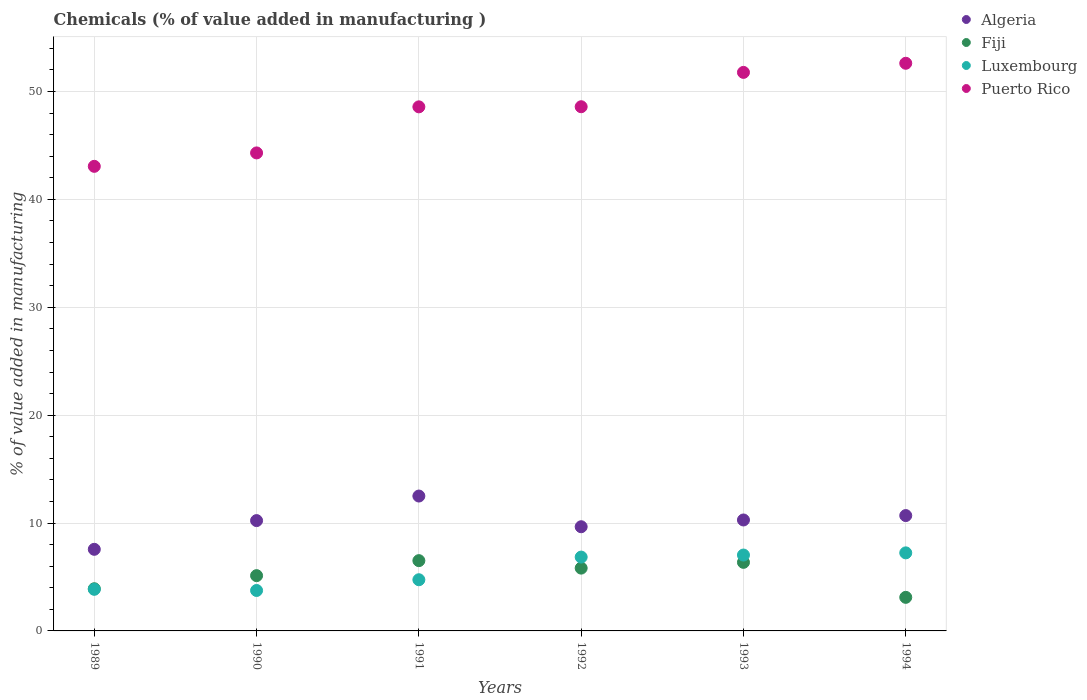How many different coloured dotlines are there?
Provide a short and direct response. 4. Is the number of dotlines equal to the number of legend labels?
Offer a terse response. Yes. What is the value added in manufacturing chemicals in Puerto Rico in 1992?
Provide a short and direct response. 48.59. Across all years, what is the maximum value added in manufacturing chemicals in Puerto Rico?
Give a very brief answer. 52.62. Across all years, what is the minimum value added in manufacturing chemicals in Luxembourg?
Offer a terse response. 3.75. In which year was the value added in manufacturing chemicals in Luxembourg maximum?
Provide a short and direct response. 1994. What is the total value added in manufacturing chemicals in Puerto Rico in the graph?
Provide a short and direct response. 288.94. What is the difference between the value added in manufacturing chemicals in Algeria in 1992 and that in 1994?
Offer a terse response. -1.03. What is the difference between the value added in manufacturing chemicals in Luxembourg in 1991 and the value added in manufacturing chemicals in Puerto Rico in 1990?
Ensure brevity in your answer.  -39.56. What is the average value added in manufacturing chemicals in Puerto Rico per year?
Provide a short and direct response. 48.16. In the year 1989, what is the difference between the value added in manufacturing chemicals in Puerto Rico and value added in manufacturing chemicals in Fiji?
Make the answer very short. 39.15. What is the ratio of the value added in manufacturing chemicals in Luxembourg in 1990 to that in 1993?
Keep it short and to the point. 0.53. Is the difference between the value added in manufacturing chemicals in Puerto Rico in 1992 and 1993 greater than the difference between the value added in manufacturing chemicals in Fiji in 1992 and 1993?
Give a very brief answer. No. What is the difference between the highest and the second highest value added in manufacturing chemicals in Puerto Rico?
Keep it short and to the point. 0.84. What is the difference between the highest and the lowest value added in manufacturing chemicals in Algeria?
Provide a short and direct response. 4.94. Is it the case that in every year, the sum of the value added in manufacturing chemicals in Puerto Rico and value added in manufacturing chemicals in Luxembourg  is greater than the sum of value added in manufacturing chemicals in Fiji and value added in manufacturing chemicals in Algeria?
Your answer should be very brief. Yes. Does the value added in manufacturing chemicals in Luxembourg monotonically increase over the years?
Provide a short and direct response. No. What is the difference between two consecutive major ticks on the Y-axis?
Provide a short and direct response. 10. Does the graph contain any zero values?
Offer a terse response. No. Where does the legend appear in the graph?
Your response must be concise. Top right. How many legend labels are there?
Provide a succinct answer. 4. What is the title of the graph?
Provide a short and direct response. Chemicals (% of value added in manufacturing ). Does "Sierra Leone" appear as one of the legend labels in the graph?
Your answer should be compact. No. What is the label or title of the Y-axis?
Your answer should be compact. % of value added in manufacturing. What is the % of value added in manufacturing of Algeria in 1989?
Your response must be concise. 7.56. What is the % of value added in manufacturing of Fiji in 1989?
Provide a short and direct response. 3.91. What is the % of value added in manufacturing of Luxembourg in 1989?
Make the answer very short. 3.86. What is the % of value added in manufacturing of Puerto Rico in 1989?
Ensure brevity in your answer.  43.07. What is the % of value added in manufacturing of Algeria in 1990?
Offer a very short reply. 10.23. What is the % of value added in manufacturing of Fiji in 1990?
Your answer should be compact. 5.12. What is the % of value added in manufacturing of Luxembourg in 1990?
Keep it short and to the point. 3.75. What is the % of value added in manufacturing in Puerto Rico in 1990?
Ensure brevity in your answer.  44.31. What is the % of value added in manufacturing of Algeria in 1991?
Provide a short and direct response. 12.5. What is the % of value added in manufacturing of Fiji in 1991?
Your answer should be compact. 6.51. What is the % of value added in manufacturing in Luxembourg in 1991?
Offer a terse response. 4.74. What is the % of value added in manufacturing of Puerto Rico in 1991?
Your answer should be compact. 48.58. What is the % of value added in manufacturing in Algeria in 1992?
Make the answer very short. 9.66. What is the % of value added in manufacturing of Fiji in 1992?
Your answer should be very brief. 5.82. What is the % of value added in manufacturing in Luxembourg in 1992?
Your answer should be compact. 6.84. What is the % of value added in manufacturing of Puerto Rico in 1992?
Give a very brief answer. 48.59. What is the % of value added in manufacturing in Algeria in 1993?
Your response must be concise. 10.28. What is the % of value added in manufacturing of Fiji in 1993?
Ensure brevity in your answer.  6.36. What is the % of value added in manufacturing in Luxembourg in 1993?
Your answer should be very brief. 7.03. What is the % of value added in manufacturing in Puerto Rico in 1993?
Keep it short and to the point. 51.77. What is the % of value added in manufacturing in Algeria in 1994?
Offer a terse response. 10.69. What is the % of value added in manufacturing of Fiji in 1994?
Offer a terse response. 3.11. What is the % of value added in manufacturing of Luxembourg in 1994?
Your response must be concise. 7.24. What is the % of value added in manufacturing of Puerto Rico in 1994?
Keep it short and to the point. 52.62. Across all years, what is the maximum % of value added in manufacturing in Algeria?
Ensure brevity in your answer.  12.5. Across all years, what is the maximum % of value added in manufacturing in Fiji?
Your response must be concise. 6.51. Across all years, what is the maximum % of value added in manufacturing of Luxembourg?
Ensure brevity in your answer.  7.24. Across all years, what is the maximum % of value added in manufacturing of Puerto Rico?
Provide a succinct answer. 52.62. Across all years, what is the minimum % of value added in manufacturing in Algeria?
Your response must be concise. 7.56. Across all years, what is the minimum % of value added in manufacturing in Fiji?
Your response must be concise. 3.11. Across all years, what is the minimum % of value added in manufacturing in Luxembourg?
Keep it short and to the point. 3.75. Across all years, what is the minimum % of value added in manufacturing in Puerto Rico?
Your answer should be compact. 43.07. What is the total % of value added in manufacturing in Algeria in the graph?
Make the answer very short. 60.93. What is the total % of value added in manufacturing of Fiji in the graph?
Provide a succinct answer. 30.84. What is the total % of value added in manufacturing of Luxembourg in the graph?
Your answer should be very brief. 33.46. What is the total % of value added in manufacturing in Puerto Rico in the graph?
Your answer should be compact. 288.94. What is the difference between the % of value added in manufacturing of Algeria in 1989 and that in 1990?
Provide a short and direct response. -2.66. What is the difference between the % of value added in manufacturing of Fiji in 1989 and that in 1990?
Keep it short and to the point. -1.21. What is the difference between the % of value added in manufacturing in Luxembourg in 1989 and that in 1990?
Your answer should be compact. 0.11. What is the difference between the % of value added in manufacturing of Puerto Rico in 1989 and that in 1990?
Offer a terse response. -1.24. What is the difference between the % of value added in manufacturing in Algeria in 1989 and that in 1991?
Give a very brief answer. -4.94. What is the difference between the % of value added in manufacturing of Fiji in 1989 and that in 1991?
Make the answer very short. -2.6. What is the difference between the % of value added in manufacturing in Luxembourg in 1989 and that in 1991?
Offer a very short reply. -0.89. What is the difference between the % of value added in manufacturing in Puerto Rico in 1989 and that in 1991?
Make the answer very short. -5.51. What is the difference between the % of value added in manufacturing in Algeria in 1989 and that in 1992?
Ensure brevity in your answer.  -2.09. What is the difference between the % of value added in manufacturing in Fiji in 1989 and that in 1992?
Your response must be concise. -1.91. What is the difference between the % of value added in manufacturing in Luxembourg in 1989 and that in 1992?
Provide a short and direct response. -2.99. What is the difference between the % of value added in manufacturing of Puerto Rico in 1989 and that in 1992?
Offer a terse response. -5.53. What is the difference between the % of value added in manufacturing of Algeria in 1989 and that in 1993?
Your response must be concise. -2.72. What is the difference between the % of value added in manufacturing in Fiji in 1989 and that in 1993?
Make the answer very short. -2.45. What is the difference between the % of value added in manufacturing of Luxembourg in 1989 and that in 1993?
Your answer should be compact. -3.18. What is the difference between the % of value added in manufacturing of Puerto Rico in 1989 and that in 1993?
Offer a terse response. -8.71. What is the difference between the % of value added in manufacturing of Algeria in 1989 and that in 1994?
Give a very brief answer. -3.13. What is the difference between the % of value added in manufacturing of Fiji in 1989 and that in 1994?
Give a very brief answer. 0.8. What is the difference between the % of value added in manufacturing in Luxembourg in 1989 and that in 1994?
Give a very brief answer. -3.38. What is the difference between the % of value added in manufacturing of Puerto Rico in 1989 and that in 1994?
Offer a very short reply. -9.55. What is the difference between the % of value added in manufacturing of Algeria in 1990 and that in 1991?
Provide a succinct answer. -2.28. What is the difference between the % of value added in manufacturing of Fiji in 1990 and that in 1991?
Offer a very short reply. -1.39. What is the difference between the % of value added in manufacturing of Luxembourg in 1990 and that in 1991?
Provide a short and direct response. -1. What is the difference between the % of value added in manufacturing in Puerto Rico in 1990 and that in 1991?
Your response must be concise. -4.27. What is the difference between the % of value added in manufacturing in Algeria in 1990 and that in 1992?
Keep it short and to the point. 0.57. What is the difference between the % of value added in manufacturing in Fiji in 1990 and that in 1992?
Your answer should be compact. -0.7. What is the difference between the % of value added in manufacturing in Luxembourg in 1990 and that in 1992?
Provide a succinct answer. -3.1. What is the difference between the % of value added in manufacturing of Puerto Rico in 1990 and that in 1992?
Offer a terse response. -4.28. What is the difference between the % of value added in manufacturing in Algeria in 1990 and that in 1993?
Provide a short and direct response. -0.06. What is the difference between the % of value added in manufacturing of Fiji in 1990 and that in 1993?
Your response must be concise. -1.23. What is the difference between the % of value added in manufacturing of Luxembourg in 1990 and that in 1993?
Keep it short and to the point. -3.29. What is the difference between the % of value added in manufacturing of Puerto Rico in 1990 and that in 1993?
Keep it short and to the point. -7.46. What is the difference between the % of value added in manufacturing in Algeria in 1990 and that in 1994?
Ensure brevity in your answer.  -0.47. What is the difference between the % of value added in manufacturing in Fiji in 1990 and that in 1994?
Your answer should be compact. 2.01. What is the difference between the % of value added in manufacturing of Luxembourg in 1990 and that in 1994?
Your response must be concise. -3.49. What is the difference between the % of value added in manufacturing in Puerto Rico in 1990 and that in 1994?
Your response must be concise. -8.31. What is the difference between the % of value added in manufacturing in Algeria in 1991 and that in 1992?
Your answer should be very brief. 2.85. What is the difference between the % of value added in manufacturing of Fiji in 1991 and that in 1992?
Provide a succinct answer. 0.69. What is the difference between the % of value added in manufacturing in Luxembourg in 1991 and that in 1992?
Your answer should be compact. -2.1. What is the difference between the % of value added in manufacturing in Puerto Rico in 1991 and that in 1992?
Keep it short and to the point. -0.01. What is the difference between the % of value added in manufacturing of Algeria in 1991 and that in 1993?
Keep it short and to the point. 2.22. What is the difference between the % of value added in manufacturing of Fiji in 1991 and that in 1993?
Offer a terse response. 0.16. What is the difference between the % of value added in manufacturing of Luxembourg in 1991 and that in 1993?
Ensure brevity in your answer.  -2.29. What is the difference between the % of value added in manufacturing in Puerto Rico in 1991 and that in 1993?
Your response must be concise. -3.19. What is the difference between the % of value added in manufacturing of Algeria in 1991 and that in 1994?
Offer a very short reply. 1.81. What is the difference between the % of value added in manufacturing of Fiji in 1991 and that in 1994?
Provide a succinct answer. 3.4. What is the difference between the % of value added in manufacturing in Luxembourg in 1991 and that in 1994?
Provide a succinct answer. -2.49. What is the difference between the % of value added in manufacturing in Puerto Rico in 1991 and that in 1994?
Offer a terse response. -4.04. What is the difference between the % of value added in manufacturing of Algeria in 1992 and that in 1993?
Ensure brevity in your answer.  -0.63. What is the difference between the % of value added in manufacturing in Fiji in 1992 and that in 1993?
Offer a very short reply. -0.53. What is the difference between the % of value added in manufacturing in Luxembourg in 1992 and that in 1993?
Offer a very short reply. -0.19. What is the difference between the % of value added in manufacturing in Puerto Rico in 1992 and that in 1993?
Your answer should be very brief. -3.18. What is the difference between the % of value added in manufacturing of Algeria in 1992 and that in 1994?
Ensure brevity in your answer.  -1.03. What is the difference between the % of value added in manufacturing of Fiji in 1992 and that in 1994?
Give a very brief answer. 2.71. What is the difference between the % of value added in manufacturing of Luxembourg in 1992 and that in 1994?
Keep it short and to the point. -0.39. What is the difference between the % of value added in manufacturing in Puerto Rico in 1992 and that in 1994?
Your answer should be very brief. -4.03. What is the difference between the % of value added in manufacturing of Algeria in 1993 and that in 1994?
Provide a short and direct response. -0.41. What is the difference between the % of value added in manufacturing of Fiji in 1993 and that in 1994?
Provide a short and direct response. 3.24. What is the difference between the % of value added in manufacturing of Luxembourg in 1993 and that in 1994?
Provide a short and direct response. -0.2. What is the difference between the % of value added in manufacturing in Puerto Rico in 1993 and that in 1994?
Give a very brief answer. -0.84. What is the difference between the % of value added in manufacturing of Algeria in 1989 and the % of value added in manufacturing of Fiji in 1990?
Offer a very short reply. 2.44. What is the difference between the % of value added in manufacturing in Algeria in 1989 and the % of value added in manufacturing in Luxembourg in 1990?
Offer a very short reply. 3.82. What is the difference between the % of value added in manufacturing of Algeria in 1989 and the % of value added in manufacturing of Puerto Rico in 1990?
Your response must be concise. -36.74. What is the difference between the % of value added in manufacturing of Fiji in 1989 and the % of value added in manufacturing of Luxembourg in 1990?
Your answer should be very brief. 0.16. What is the difference between the % of value added in manufacturing of Fiji in 1989 and the % of value added in manufacturing of Puerto Rico in 1990?
Provide a short and direct response. -40.4. What is the difference between the % of value added in manufacturing of Luxembourg in 1989 and the % of value added in manufacturing of Puerto Rico in 1990?
Make the answer very short. -40.45. What is the difference between the % of value added in manufacturing of Algeria in 1989 and the % of value added in manufacturing of Fiji in 1991?
Offer a terse response. 1.05. What is the difference between the % of value added in manufacturing in Algeria in 1989 and the % of value added in manufacturing in Luxembourg in 1991?
Your response must be concise. 2.82. What is the difference between the % of value added in manufacturing of Algeria in 1989 and the % of value added in manufacturing of Puerto Rico in 1991?
Keep it short and to the point. -41.01. What is the difference between the % of value added in manufacturing in Fiji in 1989 and the % of value added in manufacturing in Luxembourg in 1991?
Your answer should be compact. -0.83. What is the difference between the % of value added in manufacturing of Fiji in 1989 and the % of value added in manufacturing of Puerto Rico in 1991?
Provide a succinct answer. -44.67. What is the difference between the % of value added in manufacturing in Luxembourg in 1989 and the % of value added in manufacturing in Puerto Rico in 1991?
Ensure brevity in your answer.  -44.72. What is the difference between the % of value added in manufacturing in Algeria in 1989 and the % of value added in manufacturing in Fiji in 1992?
Offer a very short reply. 1.74. What is the difference between the % of value added in manufacturing in Algeria in 1989 and the % of value added in manufacturing in Luxembourg in 1992?
Your response must be concise. 0.72. What is the difference between the % of value added in manufacturing in Algeria in 1989 and the % of value added in manufacturing in Puerto Rico in 1992?
Your answer should be compact. -41.03. What is the difference between the % of value added in manufacturing of Fiji in 1989 and the % of value added in manufacturing of Luxembourg in 1992?
Provide a succinct answer. -2.93. What is the difference between the % of value added in manufacturing of Fiji in 1989 and the % of value added in manufacturing of Puerto Rico in 1992?
Provide a succinct answer. -44.68. What is the difference between the % of value added in manufacturing of Luxembourg in 1989 and the % of value added in manufacturing of Puerto Rico in 1992?
Make the answer very short. -44.73. What is the difference between the % of value added in manufacturing in Algeria in 1989 and the % of value added in manufacturing in Fiji in 1993?
Your response must be concise. 1.21. What is the difference between the % of value added in manufacturing of Algeria in 1989 and the % of value added in manufacturing of Luxembourg in 1993?
Your response must be concise. 0.53. What is the difference between the % of value added in manufacturing of Algeria in 1989 and the % of value added in manufacturing of Puerto Rico in 1993?
Offer a terse response. -44.21. What is the difference between the % of value added in manufacturing in Fiji in 1989 and the % of value added in manufacturing in Luxembourg in 1993?
Keep it short and to the point. -3.12. What is the difference between the % of value added in manufacturing of Fiji in 1989 and the % of value added in manufacturing of Puerto Rico in 1993?
Your response must be concise. -47.86. What is the difference between the % of value added in manufacturing of Luxembourg in 1989 and the % of value added in manufacturing of Puerto Rico in 1993?
Provide a short and direct response. -47.92. What is the difference between the % of value added in manufacturing of Algeria in 1989 and the % of value added in manufacturing of Fiji in 1994?
Provide a short and direct response. 4.45. What is the difference between the % of value added in manufacturing in Algeria in 1989 and the % of value added in manufacturing in Luxembourg in 1994?
Keep it short and to the point. 0.33. What is the difference between the % of value added in manufacturing in Algeria in 1989 and the % of value added in manufacturing in Puerto Rico in 1994?
Offer a very short reply. -45.05. What is the difference between the % of value added in manufacturing of Fiji in 1989 and the % of value added in manufacturing of Luxembourg in 1994?
Make the answer very short. -3.33. What is the difference between the % of value added in manufacturing of Fiji in 1989 and the % of value added in manufacturing of Puerto Rico in 1994?
Your response must be concise. -48.71. What is the difference between the % of value added in manufacturing in Luxembourg in 1989 and the % of value added in manufacturing in Puerto Rico in 1994?
Your response must be concise. -48.76. What is the difference between the % of value added in manufacturing of Algeria in 1990 and the % of value added in manufacturing of Fiji in 1991?
Your answer should be compact. 3.71. What is the difference between the % of value added in manufacturing of Algeria in 1990 and the % of value added in manufacturing of Luxembourg in 1991?
Provide a short and direct response. 5.48. What is the difference between the % of value added in manufacturing in Algeria in 1990 and the % of value added in manufacturing in Puerto Rico in 1991?
Offer a very short reply. -38.35. What is the difference between the % of value added in manufacturing in Fiji in 1990 and the % of value added in manufacturing in Luxembourg in 1991?
Give a very brief answer. 0.38. What is the difference between the % of value added in manufacturing of Fiji in 1990 and the % of value added in manufacturing of Puerto Rico in 1991?
Give a very brief answer. -43.46. What is the difference between the % of value added in manufacturing of Luxembourg in 1990 and the % of value added in manufacturing of Puerto Rico in 1991?
Keep it short and to the point. -44.83. What is the difference between the % of value added in manufacturing of Algeria in 1990 and the % of value added in manufacturing of Fiji in 1992?
Your answer should be very brief. 4.4. What is the difference between the % of value added in manufacturing of Algeria in 1990 and the % of value added in manufacturing of Luxembourg in 1992?
Give a very brief answer. 3.38. What is the difference between the % of value added in manufacturing in Algeria in 1990 and the % of value added in manufacturing in Puerto Rico in 1992?
Keep it short and to the point. -38.36. What is the difference between the % of value added in manufacturing in Fiji in 1990 and the % of value added in manufacturing in Luxembourg in 1992?
Your answer should be very brief. -1.72. What is the difference between the % of value added in manufacturing in Fiji in 1990 and the % of value added in manufacturing in Puerto Rico in 1992?
Make the answer very short. -43.47. What is the difference between the % of value added in manufacturing of Luxembourg in 1990 and the % of value added in manufacturing of Puerto Rico in 1992?
Offer a very short reply. -44.84. What is the difference between the % of value added in manufacturing in Algeria in 1990 and the % of value added in manufacturing in Fiji in 1993?
Provide a short and direct response. 3.87. What is the difference between the % of value added in manufacturing of Algeria in 1990 and the % of value added in manufacturing of Luxembourg in 1993?
Your answer should be compact. 3.19. What is the difference between the % of value added in manufacturing in Algeria in 1990 and the % of value added in manufacturing in Puerto Rico in 1993?
Make the answer very short. -41.55. What is the difference between the % of value added in manufacturing in Fiji in 1990 and the % of value added in manufacturing in Luxembourg in 1993?
Keep it short and to the point. -1.91. What is the difference between the % of value added in manufacturing of Fiji in 1990 and the % of value added in manufacturing of Puerto Rico in 1993?
Your answer should be compact. -46.65. What is the difference between the % of value added in manufacturing of Luxembourg in 1990 and the % of value added in manufacturing of Puerto Rico in 1993?
Your answer should be very brief. -48.02. What is the difference between the % of value added in manufacturing of Algeria in 1990 and the % of value added in manufacturing of Fiji in 1994?
Your response must be concise. 7.11. What is the difference between the % of value added in manufacturing in Algeria in 1990 and the % of value added in manufacturing in Luxembourg in 1994?
Offer a terse response. 2.99. What is the difference between the % of value added in manufacturing of Algeria in 1990 and the % of value added in manufacturing of Puerto Rico in 1994?
Offer a very short reply. -42.39. What is the difference between the % of value added in manufacturing of Fiji in 1990 and the % of value added in manufacturing of Luxembourg in 1994?
Your answer should be compact. -2.11. What is the difference between the % of value added in manufacturing in Fiji in 1990 and the % of value added in manufacturing in Puerto Rico in 1994?
Make the answer very short. -47.49. What is the difference between the % of value added in manufacturing in Luxembourg in 1990 and the % of value added in manufacturing in Puerto Rico in 1994?
Keep it short and to the point. -48.87. What is the difference between the % of value added in manufacturing of Algeria in 1991 and the % of value added in manufacturing of Fiji in 1992?
Offer a very short reply. 6.68. What is the difference between the % of value added in manufacturing in Algeria in 1991 and the % of value added in manufacturing in Luxembourg in 1992?
Your answer should be very brief. 5.66. What is the difference between the % of value added in manufacturing of Algeria in 1991 and the % of value added in manufacturing of Puerto Rico in 1992?
Offer a very short reply. -36.09. What is the difference between the % of value added in manufacturing in Fiji in 1991 and the % of value added in manufacturing in Luxembourg in 1992?
Give a very brief answer. -0.33. What is the difference between the % of value added in manufacturing in Fiji in 1991 and the % of value added in manufacturing in Puerto Rico in 1992?
Ensure brevity in your answer.  -42.08. What is the difference between the % of value added in manufacturing in Luxembourg in 1991 and the % of value added in manufacturing in Puerto Rico in 1992?
Your response must be concise. -43.85. What is the difference between the % of value added in manufacturing in Algeria in 1991 and the % of value added in manufacturing in Fiji in 1993?
Your answer should be very brief. 6.15. What is the difference between the % of value added in manufacturing of Algeria in 1991 and the % of value added in manufacturing of Luxembourg in 1993?
Provide a short and direct response. 5.47. What is the difference between the % of value added in manufacturing in Algeria in 1991 and the % of value added in manufacturing in Puerto Rico in 1993?
Make the answer very short. -39.27. What is the difference between the % of value added in manufacturing of Fiji in 1991 and the % of value added in manufacturing of Luxembourg in 1993?
Offer a very short reply. -0.52. What is the difference between the % of value added in manufacturing in Fiji in 1991 and the % of value added in manufacturing in Puerto Rico in 1993?
Give a very brief answer. -45.26. What is the difference between the % of value added in manufacturing of Luxembourg in 1991 and the % of value added in manufacturing of Puerto Rico in 1993?
Provide a succinct answer. -47.03. What is the difference between the % of value added in manufacturing of Algeria in 1991 and the % of value added in manufacturing of Fiji in 1994?
Ensure brevity in your answer.  9.39. What is the difference between the % of value added in manufacturing of Algeria in 1991 and the % of value added in manufacturing of Luxembourg in 1994?
Your answer should be compact. 5.27. What is the difference between the % of value added in manufacturing of Algeria in 1991 and the % of value added in manufacturing of Puerto Rico in 1994?
Offer a terse response. -40.12. What is the difference between the % of value added in manufacturing in Fiji in 1991 and the % of value added in manufacturing in Luxembourg in 1994?
Your answer should be very brief. -0.72. What is the difference between the % of value added in manufacturing in Fiji in 1991 and the % of value added in manufacturing in Puerto Rico in 1994?
Provide a succinct answer. -46.1. What is the difference between the % of value added in manufacturing in Luxembourg in 1991 and the % of value added in manufacturing in Puerto Rico in 1994?
Your response must be concise. -47.87. What is the difference between the % of value added in manufacturing of Algeria in 1992 and the % of value added in manufacturing of Fiji in 1993?
Give a very brief answer. 3.3. What is the difference between the % of value added in manufacturing of Algeria in 1992 and the % of value added in manufacturing of Luxembourg in 1993?
Your response must be concise. 2.62. What is the difference between the % of value added in manufacturing of Algeria in 1992 and the % of value added in manufacturing of Puerto Rico in 1993?
Your answer should be very brief. -42.12. What is the difference between the % of value added in manufacturing of Fiji in 1992 and the % of value added in manufacturing of Luxembourg in 1993?
Give a very brief answer. -1.21. What is the difference between the % of value added in manufacturing of Fiji in 1992 and the % of value added in manufacturing of Puerto Rico in 1993?
Offer a terse response. -45.95. What is the difference between the % of value added in manufacturing in Luxembourg in 1992 and the % of value added in manufacturing in Puerto Rico in 1993?
Offer a very short reply. -44.93. What is the difference between the % of value added in manufacturing of Algeria in 1992 and the % of value added in manufacturing of Fiji in 1994?
Your response must be concise. 6.54. What is the difference between the % of value added in manufacturing of Algeria in 1992 and the % of value added in manufacturing of Luxembourg in 1994?
Offer a very short reply. 2.42. What is the difference between the % of value added in manufacturing in Algeria in 1992 and the % of value added in manufacturing in Puerto Rico in 1994?
Your response must be concise. -42.96. What is the difference between the % of value added in manufacturing in Fiji in 1992 and the % of value added in manufacturing in Luxembourg in 1994?
Your response must be concise. -1.41. What is the difference between the % of value added in manufacturing in Fiji in 1992 and the % of value added in manufacturing in Puerto Rico in 1994?
Ensure brevity in your answer.  -46.8. What is the difference between the % of value added in manufacturing in Luxembourg in 1992 and the % of value added in manufacturing in Puerto Rico in 1994?
Your answer should be compact. -45.77. What is the difference between the % of value added in manufacturing in Algeria in 1993 and the % of value added in manufacturing in Fiji in 1994?
Your answer should be very brief. 7.17. What is the difference between the % of value added in manufacturing in Algeria in 1993 and the % of value added in manufacturing in Luxembourg in 1994?
Your response must be concise. 3.05. What is the difference between the % of value added in manufacturing in Algeria in 1993 and the % of value added in manufacturing in Puerto Rico in 1994?
Give a very brief answer. -42.33. What is the difference between the % of value added in manufacturing of Fiji in 1993 and the % of value added in manufacturing of Luxembourg in 1994?
Your response must be concise. -0.88. What is the difference between the % of value added in manufacturing of Fiji in 1993 and the % of value added in manufacturing of Puerto Rico in 1994?
Your answer should be compact. -46.26. What is the difference between the % of value added in manufacturing of Luxembourg in 1993 and the % of value added in manufacturing of Puerto Rico in 1994?
Offer a terse response. -45.58. What is the average % of value added in manufacturing of Algeria per year?
Provide a succinct answer. 10.15. What is the average % of value added in manufacturing of Fiji per year?
Give a very brief answer. 5.14. What is the average % of value added in manufacturing of Luxembourg per year?
Give a very brief answer. 5.58. What is the average % of value added in manufacturing of Puerto Rico per year?
Offer a very short reply. 48.16. In the year 1989, what is the difference between the % of value added in manufacturing in Algeria and % of value added in manufacturing in Fiji?
Give a very brief answer. 3.65. In the year 1989, what is the difference between the % of value added in manufacturing of Algeria and % of value added in manufacturing of Luxembourg?
Make the answer very short. 3.71. In the year 1989, what is the difference between the % of value added in manufacturing in Algeria and % of value added in manufacturing in Puerto Rico?
Your answer should be compact. -35.5. In the year 1989, what is the difference between the % of value added in manufacturing in Fiji and % of value added in manufacturing in Luxembourg?
Your response must be concise. 0.05. In the year 1989, what is the difference between the % of value added in manufacturing in Fiji and % of value added in manufacturing in Puerto Rico?
Provide a short and direct response. -39.15. In the year 1989, what is the difference between the % of value added in manufacturing of Luxembourg and % of value added in manufacturing of Puerto Rico?
Offer a very short reply. -39.21. In the year 1990, what is the difference between the % of value added in manufacturing of Algeria and % of value added in manufacturing of Fiji?
Keep it short and to the point. 5.1. In the year 1990, what is the difference between the % of value added in manufacturing in Algeria and % of value added in manufacturing in Luxembourg?
Your answer should be very brief. 6.48. In the year 1990, what is the difference between the % of value added in manufacturing of Algeria and % of value added in manufacturing of Puerto Rico?
Offer a terse response. -34.08. In the year 1990, what is the difference between the % of value added in manufacturing of Fiji and % of value added in manufacturing of Luxembourg?
Keep it short and to the point. 1.38. In the year 1990, what is the difference between the % of value added in manufacturing in Fiji and % of value added in manufacturing in Puerto Rico?
Offer a very short reply. -39.19. In the year 1990, what is the difference between the % of value added in manufacturing of Luxembourg and % of value added in manufacturing of Puerto Rico?
Your answer should be very brief. -40.56. In the year 1991, what is the difference between the % of value added in manufacturing in Algeria and % of value added in manufacturing in Fiji?
Provide a short and direct response. 5.99. In the year 1991, what is the difference between the % of value added in manufacturing in Algeria and % of value added in manufacturing in Luxembourg?
Provide a succinct answer. 7.76. In the year 1991, what is the difference between the % of value added in manufacturing in Algeria and % of value added in manufacturing in Puerto Rico?
Give a very brief answer. -36.08. In the year 1991, what is the difference between the % of value added in manufacturing in Fiji and % of value added in manufacturing in Luxembourg?
Your answer should be very brief. 1.77. In the year 1991, what is the difference between the % of value added in manufacturing of Fiji and % of value added in manufacturing of Puerto Rico?
Keep it short and to the point. -42.06. In the year 1991, what is the difference between the % of value added in manufacturing of Luxembourg and % of value added in manufacturing of Puerto Rico?
Provide a short and direct response. -43.83. In the year 1992, what is the difference between the % of value added in manufacturing of Algeria and % of value added in manufacturing of Fiji?
Your response must be concise. 3.84. In the year 1992, what is the difference between the % of value added in manufacturing in Algeria and % of value added in manufacturing in Luxembourg?
Provide a succinct answer. 2.81. In the year 1992, what is the difference between the % of value added in manufacturing of Algeria and % of value added in manufacturing of Puerto Rico?
Make the answer very short. -38.93. In the year 1992, what is the difference between the % of value added in manufacturing of Fiji and % of value added in manufacturing of Luxembourg?
Provide a short and direct response. -1.02. In the year 1992, what is the difference between the % of value added in manufacturing in Fiji and % of value added in manufacturing in Puerto Rico?
Provide a succinct answer. -42.77. In the year 1992, what is the difference between the % of value added in manufacturing in Luxembourg and % of value added in manufacturing in Puerto Rico?
Offer a terse response. -41.75. In the year 1993, what is the difference between the % of value added in manufacturing in Algeria and % of value added in manufacturing in Fiji?
Make the answer very short. 3.93. In the year 1993, what is the difference between the % of value added in manufacturing in Algeria and % of value added in manufacturing in Luxembourg?
Provide a short and direct response. 3.25. In the year 1993, what is the difference between the % of value added in manufacturing of Algeria and % of value added in manufacturing of Puerto Rico?
Your answer should be very brief. -41.49. In the year 1993, what is the difference between the % of value added in manufacturing of Fiji and % of value added in manufacturing of Luxembourg?
Make the answer very short. -0.68. In the year 1993, what is the difference between the % of value added in manufacturing in Fiji and % of value added in manufacturing in Puerto Rico?
Offer a terse response. -45.42. In the year 1993, what is the difference between the % of value added in manufacturing of Luxembourg and % of value added in manufacturing of Puerto Rico?
Offer a terse response. -44.74. In the year 1994, what is the difference between the % of value added in manufacturing in Algeria and % of value added in manufacturing in Fiji?
Give a very brief answer. 7.58. In the year 1994, what is the difference between the % of value added in manufacturing of Algeria and % of value added in manufacturing of Luxembourg?
Offer a terse response. 3.46. In the year 1994, what is the difference between the % of value added in manufacturing of Algeria and % of value added in manufacturing of Puerto Rico?
Keep it short and to the point. -41.93. In the year 1994, what is the difference between the % of value added in manufacturing in Fiji and % of value added in manufacturing in Luxembourg?
Offer a very short reply. -4.12. In the year 1994, what is the difference between the % of value added in manufacturing in Fiji and % of value added in manufacturing in Puerto Rico?
Ensure brevity in your answer.  -49.51. In the year 1994, what is the difference between the % of value added in manufacturing of Luxembourg and % of value added in manufacturing of Puerto Rico?
Offer a terse response. -45.38. What is the ratio of the % of value added in manufacturing of Algeria in 1989 to that in 1990?
Offer a terse response. 0.74. What is the ratio of the % of value added in manufacturing in Fiji in 1989 to that in 1990?
Your response must be concise. 0.76. What is the ratio of the % of value added in manufacturing in Luxembourg in 1989 to that in 1990?
Provide a short and direct response. 1.03. What is the ratio of the % of value added in manufacturing of Puerto Rico in 1989 to that in 1990?
Offer a terse response. 0.97. What is the ratio of the % of value added in manufacturing in Algeria in 1989 to that in 1991?
Offer a very short reply. 0.6. What is the ratio of the % of value added in manufacturing of Fiji in 1989 to that in 1991?
Provide a short and direct response. 0.6. What is the ratio of the % of value added in manufacturing of Luxembourg in 1989 to that in 1991?
Offer a very short reply. 0.81. What is the ratio of the % of value added in manufacturing in Puerto Rico in 1989 to that in 1991?
Ensure brevity in your answer.  0.89. What is the ratio of the % of value added in manufacturing of Algeria in 1989 to that in 1992?
Ensure brevity in your answer.  0.78. What is the ratio of the % of value added in manufacturing of Fiji in 1989 to that in 1992?
Offer a terse response. 0.67. What is the ratio of the % of value added in manufacturing in Luxembourg in 1989 to that in 1992?
Offer a terse response. 0.56. What is the ratio of the % of value added in manufacturing of Puerto Rico in 1989 to that in 1992?
Offer a terse response. 0.89. What is the ratio of the % of value added in manufacturing in Algeria in 1989 to that in 1993?
Provide a short and direct response. 0.74. What is the ratio of the % of value added in manufacturing in Fiji in 1989 to that in 1993?
Provide a succinct answer. 0.62. What is the ratio of the % of value added in manufacturing in Luxembourg in 1989 to that in 1993?
Provide a short and direct response. 0.55. What is the ratio of the % of value added in manufacturing of Puerto Rico in 1989 to that in 1993?
Offer a terse response. 0.83. What is the ratio of the % of value added in manufacturing of Algeria in 1989 to that in 1994?
Offer a terse response. 0.71. What is the ratio of the % of value added in manufacturing in Fiji in 1989 to that in 1994?
Ensure brevity in your answer.  1.26. What is the ratio of the % of value added in manufacturing of Luxembourg in 1989 to that in 1994?
Provide a succinct answer. 0.53. What is the ratio of the % of value added in manufacturing in Puerto Rico in 1989 to that in 1994?
Offer a terse response. 0.82. What is the ratio of the % of value added in manufacturing of Algeria in 1990 to that in 1991?
Keep it short and to the point. 0.82. What is the ratio of the % of value added in manufacturing of Fiji in 1990 to that in 1991?
Ensure brevity in your answer.  0.79. What is the ratio of the % of value added in manufacturing of Luxembourg in 1990 to that in 1991?
Offer a terse response. 0.79. What is the ratio of the % of value added in manufacturing in Puerto Rico in 1990 to that in 1991?
Give a very brief answer. 0.91. What is the ratio of the % of value added in manufacturing in Algeria in 1990 to that in 1992?
Offer a very short reply. 1.06. What is the ratio of the % of value added in manufacturing of Fiji in 1990 to that in 1992?
Your response must be concise. 0.88. What is the ratio of the % of value added in manufacturing of Luxembourg in 1990 to that in 1992?
Ensure brevity in your answer.  0.55. What is the ratio of the % of value added in manufacturing in Puerto Rico in 1990 to that in 1992?
Offer a terse response. 0.91. What is the ratio of the % of value added in manufacturing in Algeria in 1990 to that in 1993?
Your response must be concise. 0.99. What is the ratio of the % of value added in manufacturing of Fiji in 1990 to that in 1993?
Make the answer very short. 0.81. What is the ratio of the % of value added in manufacturing of Luxembourg in 1990 to that in 1993?
Make the answer very short. 0.53. What is the ratio of the % of value added in manufacturing in Puerto Rico in 1990 to that in 1993?
Give a very brief answer. 0.86. What is the ratio of the % of value added in manufacturing in Algeria in 1990 to that in 1994?
Provide a short and direct response. 0.96. What is the ratio of the % of value added in manufacturing of Fiji in 1990 to that in 1994?
Your answer should be very brief. 1.65. What is the ratio of the % of value added in manufacturing of Luxembourg in 1990 to that in 1994?
Give a very brief answer. 0.52. What is the ratio of the % of value added in manufacturing in Puerto Rico in 1990 to that in 1994?
Your answer should be very brief. 0.84. What is the ratio of the % of value added in manufacturing in Algeria in 1991 to that in 1992?
Your answer should be compact. 1.29. What is the ratio of the % of value added in manufacturing of Fiji in 1991 to that in 1992?
Your answer should be compact. 1.12. What is the ratio of the % of value added in manufacturing of Luxembourg in 1991 to that in 1992?
Make the answer very short. 0.69. What is the ratio of the % of value added in manufacturing in Puerto Rico in 1991 to that in 1992?
Give a very brief answer. 1. What is the ratio of the % of value added in manufacturing of Algeria in 1991 to that in 1993?
Keep it short and to the point. 1.22. What is the ratio of the % of value added in manufacturing in Luxembourg in 1991 to that in 1993?
Make the answer very short. 0.67. What is the ratio of the % of value added in manufacturing in Puerto Rico in 1991 to that in 1993?
Your answer should be very brief. 0.94. What is the ratio of the % of value added in manufacturing in Algeria in 1991 to that in 1994?
Provide a short and direct response. 1.17. What is the ratio of the % of value added in manufacturing in Fiji in 1991 to that in 1994?
Make the answer very short. 2.09. What is the ratio of the % of value added in manufacturing of Luxembourg in 1991 to that in 1994?
Give a very brief answer. 0.66. What is the ratio of the % of value added in manufacturing in Puerto Rico in 1991 to that in 1994?
Provide a succinct answer. 0.92. What is the ratio of the % of value added in manufacturing of Algeria in 1992 to that in 1993?
Provide a succinct answer. 0.94. What is the ratio of the % of value added in manufacturing in Fiji in 1992 to that in 1993?
Your answer should be very brief. 0.92. What is the ratio of the % of value added in manufacturing in Luxembourg in 1992 to that in 1993?
Provide a short and direct response. 0.97. What is the ratio of the % of value added in manufacturing in Puerto Rico in 1992 to that in 1993?
Give a very brief answer. 0.94. What is the ratio of the % of value added in manufacturing in Algeria in 1992 to that in 1994?
Make the answer very short. 0.9. What is the ratio of the % of value added in manufacturing in Fiji in 1992 to that in 1994?
Provide a short and direct response. 1.87. What is the ratio of the % of value added in manufacturing in Luxembourg in 1992 to that in 1994?
Your answer should be compact. 0.95. What is the ratio of the % of value added in manufacturing of Puerto Rico in 1992 to that in 1994?
Provide a short and direct response. 0.92. What is the ratio of the % of value added in manufacturing in Algeria in 1993 to that in 1994?
Offer a terse response. 0.96. What is the ratio of the % of value added in manufacturing in Fiji in 1993 to that in 1994?
Keep it short and to the point. 2.04. What is the ratio of the % of value added in manufacturing of Luxembourg in 1993 to that in 1994?
Provide a succinct answer. 0.97. What is the ratio of the % of value added in manufacturing of Puerto Rico in 1993 to that in 1994?
Offer a very short reply. 0.98. What is the difference between the highest and the second highest % of value added in manufacturing of Algeria?
Offer a very short reply. 1.81. What is the difference between the highest and the second highest % of value added in manufacturing of Fiji?
Ensure brevity in your answer.  0.16. What is the difference between the highest and the second highest % of value added in manufacturing in Luxembourg?
Your response must be concise. 0.2. What is the difference between the highest and the second highest % of value added in manufacturing of Puerto Rico?
Your answer should be compact. 0.84. What is the difference between the highest and the lowest % of value added in manufacturing of Algeria?
Give a very brief answer. 4.94. What is the difference between the highest and the lowest % of value added in manufacturing of Fiji?
Offer a very short reply. 3.4. What is the difference between the highest and the lowest % of value added in manufacturing of Luxembourg?
Your answer should be very brief. 3.49. What is the difference between the highest and the lowest % of value added in manufacturing in Puerto Rico?
Offer a terse response. 9.55. 